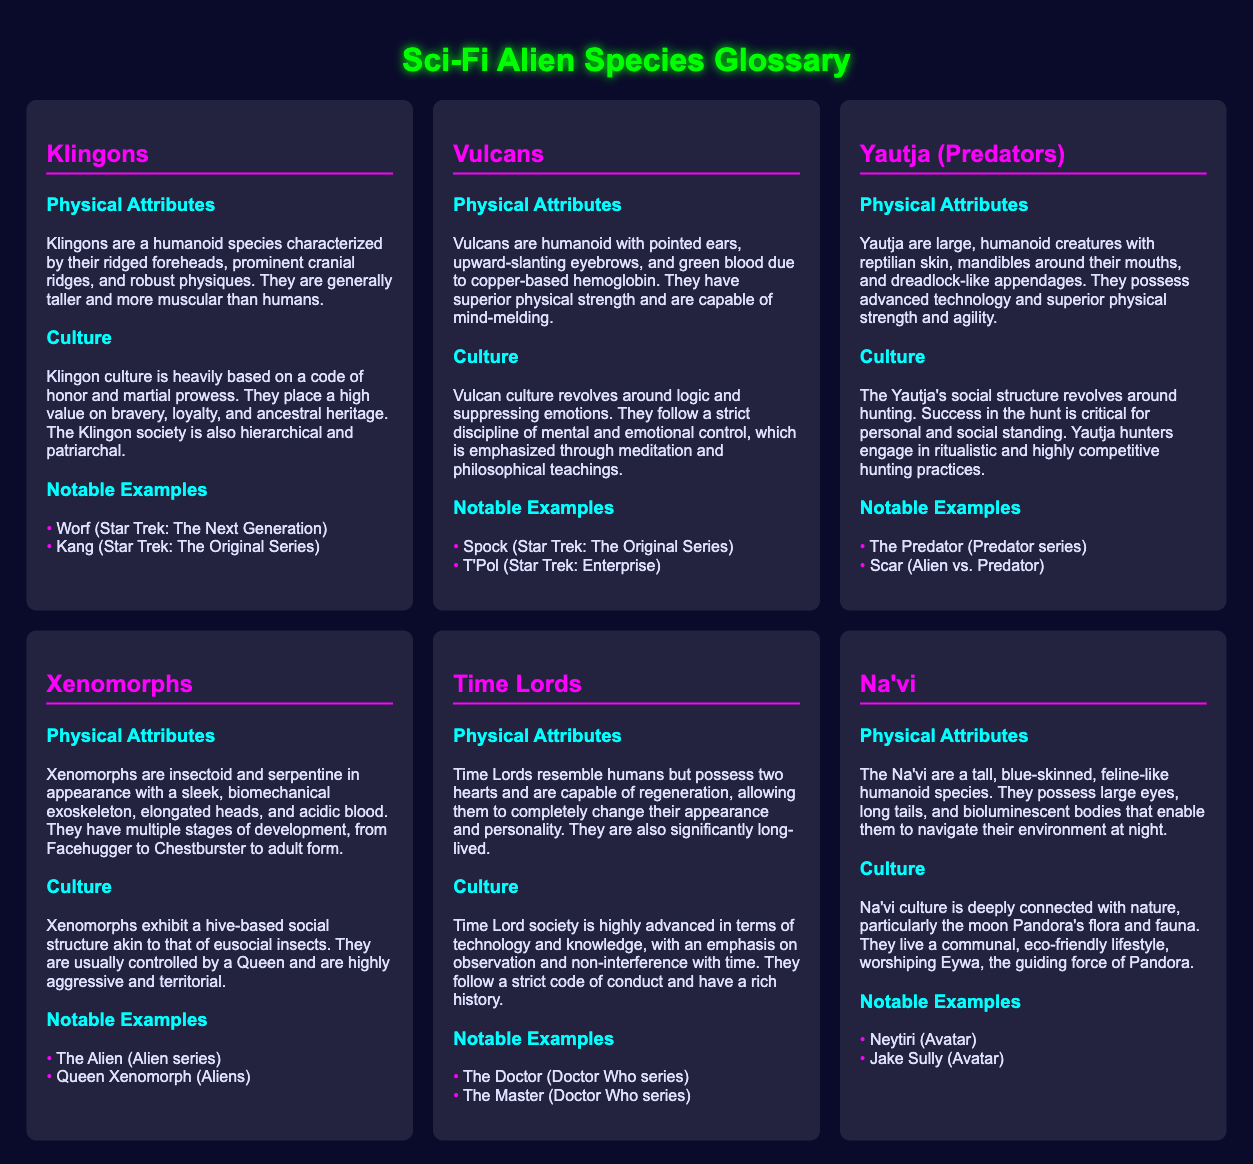What are the physical attributes of Klingons? The physical attributes of Klingons include their ridged foreheads, prominent cranial ridges, and robust physiques.
Answer: Ridged foreheads, prominent cranial ridges, robust physiques What is the notable example of a Vulcan? The notable examples of Vulcans are Spock and T'Pol.
Answer: Spock How do Yautja determine personal and social standing? Yautja determine personal and social standing through success in the hunt.
Answer: Success in the hunt What is a key cultural aspect of the Na'vi? A key cultural aspect of the Na'vi is their connection with nature and worship of Eywa.
Answer: Connection with nature, worship Eywa How many hearts do Time Lords possess? Time Lords possess two hearts.
Answer: Two hearts What is the hive-based structure of Xenomorphs similar to? The hive-based structure of Xenomorphs is similar to that of eusocial insects.
Answer: Eusocial insects What distinctive physical feature do Vulcans have? Vulcans have pointed ears and upward-slanting eyebrows.
Answer: Pointed ears, upward-slanting eyebrows What does Klingon culture highly value? Klingon culture highly values bravery, loyalty, and ancestral heritage.
Answer: Bravery, loyalty, ancestral heritage What is the primary focus of Na'vi culture? The primary focus of Na'vi culture is an eco-friendly lifestyle and connection to nature.
Answer: Eco-friendly lifestyle, connection to nature 